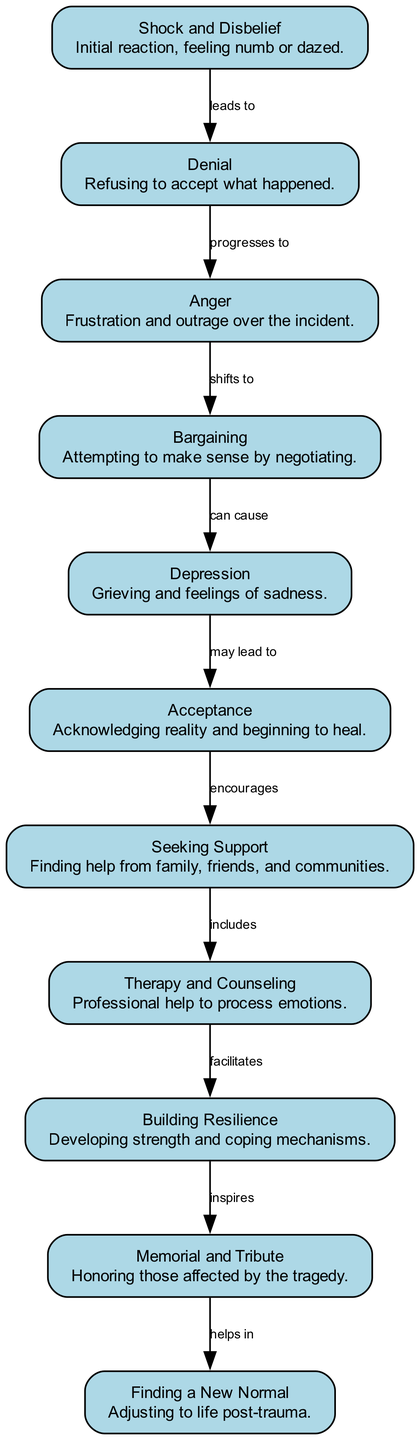What is the first stage of grief according to the diagram? The diagram lists "Shock and Disbelief" as a node at the beginning of the emotional roller coaster. This node represents the initial reaction of survivors.
Answer: Shock and Disbelief How many stages are depicted in the diagram? By counting the nodes listed in the diagram, we find there are eleven stages representing different emotional states and processes.
Answer: 11 What stage comes after "Denial"? Following the flow of connections in the diagram, "Denial" is linked to "Anger," which is its immediate successor in the emotional journey.
Answer: Anger What is the relationship between "Acceptance" and "Seeking Support"? The diagram shows that "Acceptance" encourages "Seeking Support," indicating that as individuals reach acceptance, they are more likely to seek assistance from others.
Answer: encourages Which stage can be a precursor to "Depression"? The diagram indicates that "Bargaining" can cause "Depression," highlighting that attempting to negotiate or make sense of the situation may lead to deeper feelings of sadness.
Answer: Bargaining What helps in finding a "New Normal"? The diagram illustrates that "Memorial and Tribute" helps in the process of finding a "New Normal," indicating the importance of honoring those affected while adjusting to life post-trauma.
Answer: helps in What stage directly follows "Therapy and Counseling"? The diagram shows that "Therapy and Counseling" facilitates the development of "Building Resilience," which directly follows in the progression.
Answer: Building Resilience Are there any edges that connect a stage focused on grief directly to positive outcomes? Yes, there are edges from stages like "Acceptance," which leads to "Seeking Support," and subsequently to "Therapy and Counseling," contributing to positive outcomes like "Building Resilience" and eventually "Finding a New Normal."
Answer: Yes How does "Depression" relate to "Acceptance"? The diagram indicates that "Depression" may lead to "Acceptance," suggesting that experiencing sadness can be part of the journey towards acknowledging reality and beginning healing.
Answer: may lead to 